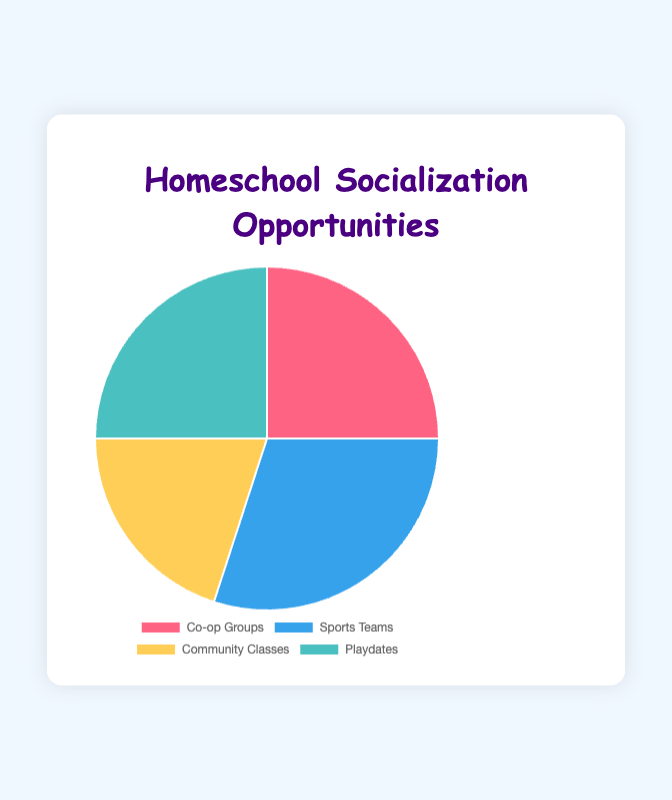What socialization opportunity has the largest percentage? The largest percentage is shown next to "Sports Teams" which has 30%.
Answer: Sports Teams Which socialization opportunities have the same percentage? Both "Co-op Groups" and "Playdates" share the same percentage, each having 25%.
Answer: Co-op Groups and Playdates How much more percentage do "Sports Teams" have compared to "Community Classes"? "Sports Teams" has 30%, and "Community Classes" has 20%. The difference is calculated as 30% - 20% = 10%.
Answer: 10% Which socialization opportunity has the smallest percentage? The smallest percentage is shown next to "Community Classes" which has 20%.
Answer: Community Classes What is the total percentage for all opportunities combined? Adding up all percentages: 25% (Co-op Groups) + 30% (Sports Teams) + 20% (Community Classes) + 25% (Playdates) = 100%.
Answer: 100% Which two socialization opportunities together make up exactly half of the total percentage? "Co-op Groups" and "Playdates" each have 25%, combined they make 25% + 25% = 50%.
Answer: Co-op Groups and Playdates What is the average percentage of the four socialization opportunities? Sum of the percentages: 25% + 30% + 20% + 25% = 100%. Average = 100% / 4 = 25%.
Answer: 25% What visual color is used for "Community Classes"? The pie chart shows "Community Classes" colored in yellow.
Answer: Yellow Which socialization opportunity is represented by the color blue? "Sports Teams" are represented by the color blue in the pie chart.
Answer: Sports Teams 